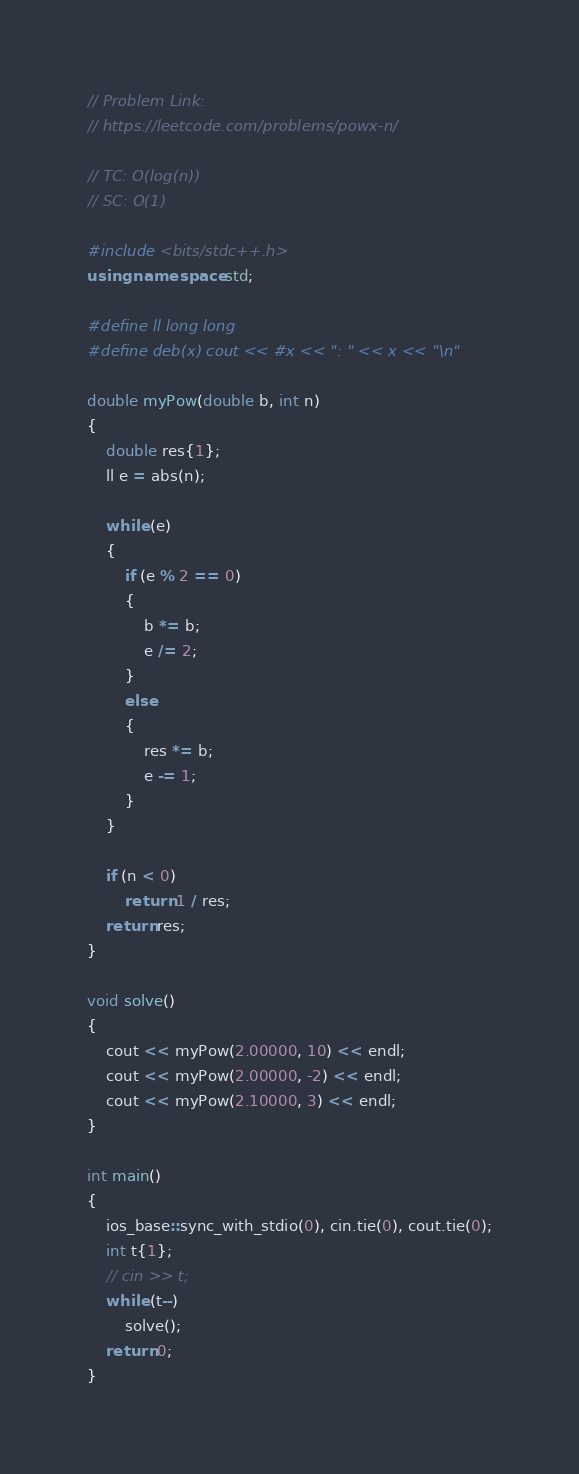Convert code to text. <code><loc_0><loc_0><loc_500><loc_500><_C++_>// Problem Link:
// https://leetcode.com/problems/powx-n/

// TC: O(log(n))
// SC: O(1)

#include <bits/stdc++.h>
using namespace std;

#define ll long long
#define deb(x) cout << #x << ": " << x << "\n"

double myPow(double b, int n)
{
    double res{1};
    ll e = abs(n);

    while (e)
    {
        if (e % 2 == 0)
        {
            b *= b;
            e /= 2;
        }
        else
        {
            res *= b;
            e -= 1;
        }
    }

    if (n < 0)
        return 1 / res;
    return res;
}

void solve()
{
    cout << myPow(2.00000, 10) << endl;
    cout << myPow(2.00000, -2) << endl;
    cout << myPow(2.10000, 3) << endl;
}

int main()
{
    ios_base::sync_with_stdio(0), cin.tie(0), cout.tie(0);
    int t{1};
    // cin >> t;
    while (t--)
        solve();
    return 0;
}</code> 